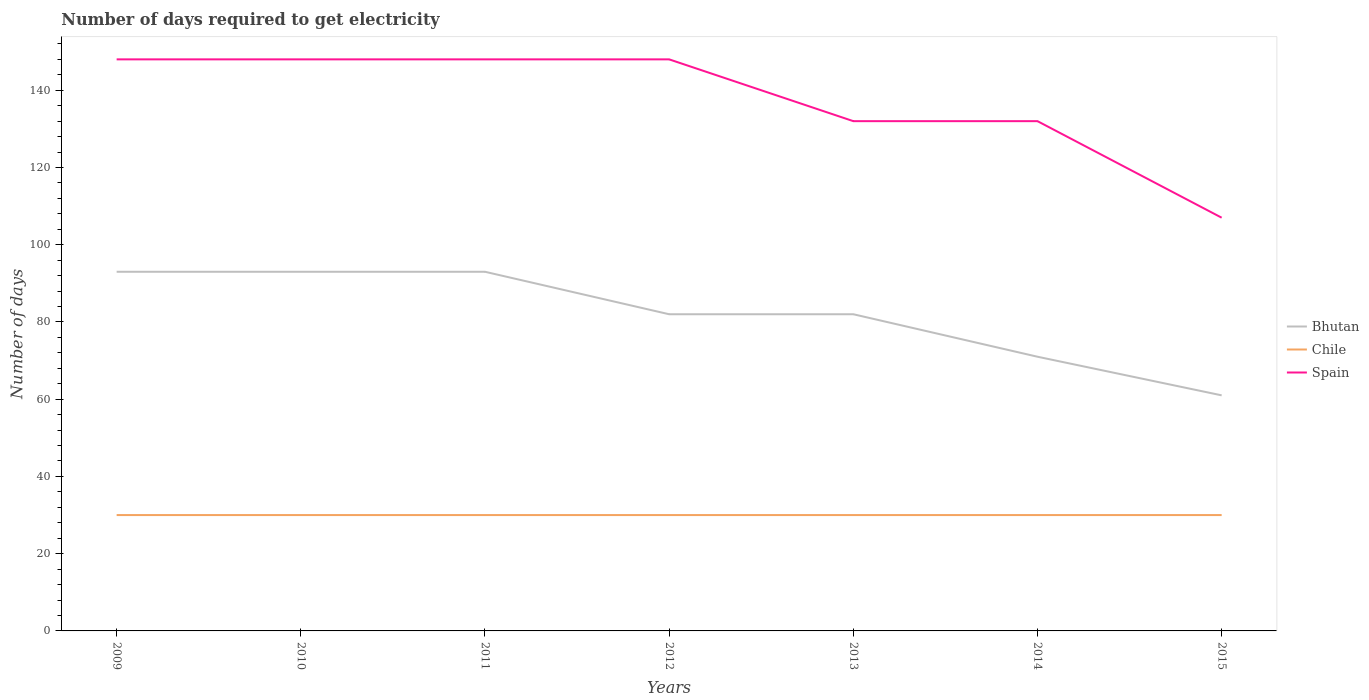Is the number of lines equal to the number of legend labels?
Provide a short and direct response. Yes. Across all years, what is the maximum number of days required to get electricity in in Chile?
Make the answer very short. 30. In which year was the number of days required to get electricity in in Bhutan maximum?
Your answer should be very brief. 2015. What is the total number of days required to get electricity in in Spain in the graph?
Keep it short and to the point. 0. What is the difference between the highest and the second highest number of days required to get electricity in in Chile?
Keep it short and to the point. 0. Is the number of days required to get electricity in in Spain strictly greater than the number of days required to get electricity in in Chile over the years?
Offer a very short reply. No. Where does the legend appear in the graph?
Your answer should be compact. Center right. How many legend labels are there?
Your answer should be very brief. 3. How are the legend labels stacked?
Your answer should be very brief. Vertical. What is the title of the graph?
Your response must be concise. Number of days required to get electricity. What is the label or title of the Y-axis?
Make the answer very short. Number of days. What is the Number of days of Bhutan in 2009?
Provide a succinct answer. 93. What is the Number of days in Spain in 2009?
Ensure brevity in your answer.  148. What is the Number of days in Bhutan in 2010?
Keep it short and to the point. 93. What is the Number of days of Chile in 2010?
Provide a short and direct response. 30. What is the Number of days in Spain in 2010?
Provide a succinct answer. 148. What is the Number of days in Bhutan in 2011?
Your answer should be very brief. 93. What is the Number of days of Chile in 2011?
Your answer should be very brief. 30. What is the Number of days of Spain in 2011?
Give a very brief answer. 148. What is the Number of days of Spain in 2012?
Your response must be concise. 148. What is the Number of days of Bhutan in 2013?
Ensure brevity in your answer.  82. What is the Number of days in Spain in 2013?
Your answer should be very brief. 132. What is the Number of days of Spain in 2014?
Provide a short and direct response. 132. What is the Number of days in Chile in 2015?
Your answer should be very brief. 30. What is the Number of days in Spain in 2015?
Give a very brief answer. 107. Across all years, what is the maximum Number of days of Bhutan?
Provide a short and direct response. 93. Across all years, what is the maximum Number of days of Spain?
Your answer should be compact. 148. Across all years, what is the minimum Number of days in Bhutan?
Provide a succinct answer. 61. Across all years, what is the minimum Number of days in Spain?
Keep it short and to the point. 107. What is the total Number of days in Bhutan in the graph?
Your answer should be very brief. 575. What is the total Number of days of Chile in the graph?
Give a very brief answer. 210. What is the total Number of days in Spain in the graph?
Offer a terse response. 963. What is the difference between the Number of days in Chile in 2009 and that in 2010?
Offer a very short reply. 0. What is the difference between the Number of days in Spain in 2009 and that in 2010?
Provide a short and direct response. 0. What is the difference between the Number of days of Spain in 2009 and that in 2011?
Provide a short and direct response. 0. What is the difference between the Number of days in Chile in 2009 and that in 2012?
Provide a short and direct response. 0. What is the difference between the Number of days in Bhutan in 2009 and that in 2013?
Your response must be concise. 11. What is the difference between the Number of days in Chile in 2009 and that in 2013?
Make the answer very short. 0. What is the difference between the Number of days in Bhutan in 2009 and that in 2014?
Make the answer very short. 22. What is the difference between the Number of days in Chile in 2009 and that in 2014?
Your answer should be compact. 0. What is the difference between the Number of days in Bhutan in 2009 and that in 2015?
Your answer should be very brief. 32. What is the difference between the Number of days of Chile in 2009 and that in 2015?
Provide a short and direct response. 0. What is the difference between the Number of days of Spain in 2009 and that in 2015?
Give a very brief answer. 41. What is the difference between the Number of days of Chile in 2010 and that in 2011?
Ensure brevity in your answer.  0. What is the difference between the Number of days in Chile in 2010 and that in 2014?
Your answer should be compact. 0. What is the difference between the Number of days of Spain in 2010 and that in 2014?
Keep it short and to the point. 16. What is the difference between the Number of days of Chile in 2010 and that in 2015?
Provide a short and direct response. 0. What is the difference between the Number of days in Chile in 2011 and that in 2012?
Your answer should be compact. 0. What is the difference between the Number of days in Spain in 2011 and that in 2013?
Offer a terse response. 16. What is the difference between the Number of days of Chile in 2011 and that in 2014?
Provide a succinct answer. 0. What is the difference between the Number of days of Spain in 2011 and that in 2014?
Offer a terse response. 16. What is the difference between the Number of days in Spain in 2011 and that in 2015?
Ensure brevity in your answer.  41. What is the difference between the Number of days of Chile in 2012 and that in 2013?
Make the answer very short. 0. What is the difference between the Number of days of Bhutan in 2012 and that in 2014?
Keep it short and to the point. 11. What is the difference between the Number of days in Chile in 2012 and that in 2014?
Your answer should be very brief. 0. What is the difference between the Number of days in Spain in 2012 and that in 2014?
Your response must be concise. 16. What is the difference between the Number of days in Bhutan in 2012 and that in 2015?
Offer a terse response. 21. What is the difference between the Number of days of Bhutan in 2013 and that in 2014?
Offer a terse response. 11. What is the difference between the Number of days in Chile in 2013 and that in 2015?
Give a very brief answer. 0. What is the difference between the Number of days in Spain in 2013 and that in 2015?
Offer a terse response. 25. What is the difference between the Number of days in Bhutan in 2014 and that in 2015?
Ensure brevity in your answer.  10. What is the difference between the Number of days in Chile in 2014 and that in 2015?
Your answer should be very brief. 0. What is the difference between the Number of days in Bhutan in 2009 and the Number of days in Chile in 2010?
Offer a terse response. 63. What is the difference between the Number of days of Bhutan in 2009 and the Number of days of Spain in 2010?
Keep it short and to the point. -55. What is the difference between the Number of days of Chile in 2009 and the Number of days of Spain in 2010?
Your response must be concise. -118. What is the difference between the Number of days in Bhutan in 2009 and the Number of days in Chile in 2011?
Ensure brevity in your answer.  63. What is the difference between the Number of days of Bhutan in 2009 and the Number of days of Spain in 2011?
Your answer should be compact. -55. What is the difference between the Number of days in Chile in 2009 and the Number of days in Spain in 2011?
Offer a very short reply. -118. What is the difference between the Number of days of Bhutan in 2009 and the Number of days of Chile in 2012?
Provide a succinct answer. 63. What is the difference between the Number of days of Bhutan in 2009 and the Number of days of Spain in 2012?
Provide a short and direct response. -55. What is the difference between the Number of days in Chile in 2009 and the Number of days in Spain in 2012?
Your answer should be compact. -118. What is the difference between the Number of days in Bhutan in 2009 and the Number of days in Chile in 2013?
Your response must be concise. 63. What is the difference between the Number of days of Bhutan in 2009 and the Number of days of Spain in 2013?
Provide a short and direct response. -39. What is the difference between the Number of days in Chile in 2009 and the Number of days in Spain in 2013?
Your response must be concise. -102. What is the difference between the Number of days of Bhutan in 2009 and the Number of days of Spain in 2014?
Keep it short and to the point. -39. What is the difference between the Number of days of Chile in 2009 and the Number of days of Spain in 2014?
Ensure brevity in your answer.  -102. What is the difference between the Number of days in Bhutan in 2009 and the Number of days in Chile in 2015?
Ensure brevity in your answer.  63. What is the difference between the Number of days of Bhutan in 2009 and the Number of days of Spain in 2015?
Provide a succinct answer. -14. What is the difference between the Number of days in Chile in 2009 and the Number of days in Spain in 2015?
Your response must be concise. -77. What is the difference between the Number of days of Bhutan in 2010 and the Number of days of Chile in 2011?
Provide a short and direct response. 63. What is the difference between the Number of days in Bhutan in 2010 and the Number of days in Spain in 2011?
Your answer should be compact. -55. What is the difference between the Number of days in Chile in 2010 and the Number of days in Spain in 2011?
Offer a very short reply. -118. What is the difference between the Number of days of Bhutan in 2010 and the Number of days of Spain in 2012?
Offer a very short reply. -55. What is the difference between the Number of days of Chile in 2010 and the Number of days of Spain in 2012?
Offer a terse response. -118. What is the difference between the Number of days in Bhutan in 2010 and the Number of days in Chile in 2013?
Provide a succinct answer. 63. What is the difference between the Number of days of Bhutan in 2010 and the Number of days of Spain in 2013?
Your answer should be very brief. -39. What is the difference between the Number of days in Chile in 2010 and the Number of days in Spain in 2013?
Offer a very short reply. -102. What is the difference between the Number of days in Bhutan in 2010 and the Number of days in Spain in 2014?
Offer a very short reply. -39. What is the difference between the Number of days in Chile in 2010 and the Number of days in Spain in 2014?
Your answer should be compact. -102. What is the difference between the Number of days in Bhutan in 2010 and the Number of days in Chile in 2015?
Offer a terse response. 63. What is the difference between the Number of days in Chile in 2010 and the Number of days in Spain in 2015?
Your answer should be compact. -77. What is the difference between the Number of days in Bhutan in 2011 and the Number of days in Spain in 2012?
Ensure brevity in your answer.  -55. What is the difference between the Number of days in Chile in 2011 and the Number of days in Spain in 2012?
Offer a terse response. -118. What is the difference between the Number of days in Bhutan in 2011 and the Number of days in Chile in 2013?
Your response must be concise. 63. What is the difference between the Number of days in Bhutan in 2011 and the Number of days in Spain in 2013?
Your response must be concise. -39. What is the difference between the Number of days of Chile in 2011 and the Number of days of Spain in 2013?
Give a very brief answer. -102. What is the difference between the Number of days of Bhutan in 2011 and the Number of days of Spain in 2014?
Provide a short and direct response. -39. What is the difference between the Number of days of Chile in 2011 and the Number of days of Spain in 2014?
Ensure brevity in your answer.  -102. What is the difference between the Number of days of Bhutan in 2011 and the Number of days of Chile in 2015?
Keep it short and to the point. 63. What is the difference between the Number of days of Bhutan in 2011 and the Number of days of Spain in 2015?
Provide a succinct answer. -14. What is the difference between the Number of days of Chile in 2011 and the Number of days of Spain in 2015?
Keep it short and to the point. -77. What is the difference between the Number of days of Bhutan in 2012 and the Number of days of Chile in 2013?
Provide a succinct answer. 52. What is the difference between the Number of days of Bhutan in 2012 and the Number of days of Spain in 2013?
Make the answer very short. -50. What is the difference between the Number of days in Chile in 2012 and the Number of days in Spain in 2013?
Your answer should be compact. -102. What is the difference between the Number of days of Chile in 2012 and the Number of days of Spain in 2014?
Make the answer very short. -102. What is the difference between the Number of days of Bhutan in 2012 and the Number of days of Chile in 2015?
Offer a very short reply. 52. What is the difference between the Number of days in Chile in 2012 and the Number of days in Spain in 2015?
Ensure brevity in your answer.  -77. What is the difference between the Number of days in Bhutan in 2013 and the Number of days in Chile in 2014?
Your response must be concise. 52. What is the difference between the Number of days of Bhutan in 2013 and the Number of days of Spain in 2014?
Provide a succinct answer. -50. What is the difference between the Number of days in Chile in 2013 and the Number of days in Spain in 2014?
Offer a terse response. -102. What is the difference between the Number of days of Bhutan in 2013 and the Number of days of Chile in 2015?
Ensure brevity in your answer.  52. What is the difference between the Number of days in Chile in 2013 and the Number of days in Spain in 2015?
Ensure brevity in your answer.  -77. What is the difference between the Number of days of Bhutan in 2014 and the Number of days of Spain in 2015?
Your response must be concise. -36. What is the difference between the Number of days in Chile in 2014 and the Number of days in Spain in 2015?
Keep it short and to the point. -77. What is the average Number of days in Bhutan per year?
Your response must be concise. 82.14. What is the average Number of days in Chile per year?
Offer a very short reply. 30. What is the average Number of days in Spain per year?
Your answer should be very brief. 137.57. In the year 2009, what is the difference between the Number of days of Bhutan and Number of days of Spain?
Your answer should be compact. -55. In the year 2009, what is the difference between the Number of days in Chile and Number of days in Spain?
Your response must be concise. -118. In the year 2010, what is the difference between the Number of days of Bhutan and Number of days of Spain?
Provide a succinct answer. -55. In the year 2010, what is the difference between the Number of days in Chile and Number of days in Spain?
Provide a short and direct response. -118. In the year 2011, what is the difference between the Number of days of Bhutan and Number of days of Spain?
Provide a short and direct response. -55. In the year 2011, what is the difference between the Number of days in Chile and Number of days in Spain?
Your response must be concise. -118. In the year 2012, what is the difference between the Number of days in Bhutan and Number of days in Chile?
Keep it short and to the point. 52. In the year 2012, what is the difference between the Number of days in Bhutan and Number of days in Spain?
Keep it short and to the point. -66. In the year 2012, what is the difference between the Number of days of Chile and Number of days of Spain?
Give a very brief answer. -118. In the year 2013, what is the difference between the Number of days of Bhutan and Number of days of Chile?
Your answer should be very brief. 52. In the year 2013, what is the difference between the Number of days of Bhutan and Number of days of Spain?
Make the answer very short. -50. In the year 2013, what is the difference between the Number of days of Chile and Number of days of Spain?
Offer a terse response. -102. In the year 2014, what is the difference between the Number of days of Bhutan and Number of days of Spain?
Provide a succinct answer. -61. In the year 2014, what is the difference between the Number of days of Chile and Number of days of Spain?
Ensure brevity in your answer.  -102. In the year 2015, what is the difference between the Number of days of Bhutan and Number of days of Chile?
Your answer should be compact. 31. In the year 2015, what is the difference between the Number of days of Bhutan and Number of days of Spain?
Your answer should be very brief. -46. In the year 2015, what is the difference between the Number of days in Chile and Number of days in Spain?
Offer a terse response. -77. What is the ratio of the Number of days of Spain in 2009 to that in 2010?
Make the answer very short. 1. What is the ratio of the Number of days in Bhutan in 2009 to that in 2012?
Ensure brevity in your answer.  1.13. What is the ratio of the Number of days of Chile in 2009 to that in 2012?
Make the answer very short. 1. What is the ratio of the Number of days in Bhutan in 2009 to that in 2013?
Provide a succinct answer. 1.13. What is the ratio of the Number of days of Chile in 2009 to that in 2013?
Provide a short and direct response. 1. What is the ratio of the Number of days in Spain in 2009 to that in 2013?
Make the answer very short. 1.12. What is the ratio of the Number of days of Bhutan in 2009 to that in 2014?
Your answer should be very brief. 1.31. What is the ratio of the Number of days in Spain in 2009 to that in 2014?
Provide a short and direct response. 1.12. What is the ratio of the Number of days of Bhutan in 2009 to that in 2015?
Your answer should be very brief. 1.52. What is the ratio of the Number of days in Chile in 2009 to that in 2015?
Provide a succinct answer. 1. What is the ratio of the Number of days of Spain in 2009 to that in 2015?
Keep it short and to the point. 1.38. What is the ratio of the Number of days of Bhutan in 2010 to that in 2011?
Your answer should be compact. 1. What is the ratio of the Number of days in Chile in 2010 to that in 2011?
Give a very brief answer. 1. What is the ratio of the Number of days of Spain in 2010 to that in 2011?
Offer a terse response. 1. What is the ratio of the Number of days in Bhutan in 2010 to that in 2012?
Your response must be concise. 1.13. What is the ratio of the Number of days in Bhutan in 2010 to that in 2013?
Keep it short and to the point. 1.13. What is the ratio of the Number of days of Spain in 2010 to that in 2013?
Provide a short and direct response. 1.12. What is the ratio of the Number of days in Bhutan in 2010 to that in 2014?
Provide a short and direct response. 1.31. What is the ratio of the Number of days of Spain in 2010 to that in 2014?
Your response must be concise. 1.12. What is the ratio of the Number of days of Bhutan in 2010 to that in 2015?
Keep it short and to the point. 1.52. What is the ratio of the Number of days of Spain in 2010 to that in 2015?
Make the answer very short. 1.38. What is the ratio of the Number of days of Bhutan in 2011 to that in 2012?
Ensure brevity in your answer.  1.13. What is the ratio of the Number of days in Spain in 2011 to that in 2012?
Your response must be concise. 1. What is the ratio of the Number of days of Bhutan in 2011 to that in 2013?
Your answer should be very brief. 1.13. What is the ratio of the Number of days of Spain in 2011 to that in 2013?
Your answer should be compact. 1.12. What is the ratio of the Number of days in Bhutan in 2011 to that in 2014?
Your response must be concise. 1.31. What is the ratio of the Number of days of Spain in 2011 to that in 2014?
Provide a short and direct response. 1.12. What is the ratio of the Number of days of Bhutan in 2011 to that in 2015?
Your answer should be very brief. 1.52. What is the ratio of the Number of days of Spain in 2011 to that in 2015?
Ensure brevity in your answer.  1.38. What is the ratio of the Number of days in Bhutan in 2012 to that in 2013?
Your response must be concise. 1. What is the ratio of the Number of days in Chile in 2012 to that in 2013?
Your answer should be very brief. 1. What is the ratio of the Number of days in Spain in 2012 to that in 2013?
Provide a succinct answer. 1.12. What is the ratio of the Number of days of Bhutan in 2012 to that in 2014?
Your answer should be compact. 1.15. What is the ratio of the Number of days of Chile in 2012 to that in 2014?
Your response must be concise. 1. What is the ratio of the Number of days of Spain in 2012 to that in 2014?
Provide a short and direct response. 1.12. What is the ratio of the Number of days in Bhutan in 2012 to that in 2015?
Your response must be concise. 1.34. What is the ratio of the Number of days in Chile in 2012 to that in 2015?
Your answer should be very brief. 1. What is the ratio of the Number of days of Spain in 2012 to that in 2015?
Give a very brief answer. 1.38. What is the ratio of the Number of days of Bhutan in 2013 to that in 2014?
Provide a short and direct response. 1.15. What is the ratio of the Number of days of Spain in 2013 to that in 2014?
Provide a short and direct response. 1. What is the ratio of the Number of days in Bhutan in 2013 to that in 2015?
Ensure brevity in your answer.  1.34. What is the ratio of the Number of days of Spain in 2013 to that in 2015?
Your answer should be compact. 1.23. What is the ratio of the Number of days of Bhutan in 2014 to that in 2015?
Your response must be concise. 1.16. What is the ratio of the Number of days of Spain in 2014 to that in 2015?
Offer a terse response. 1.23. What is the difference between the highest and the second highest Number of days of Bhutan?
Provide a short and direct response. 0. What is the difference between the highest and the second highest Number of days in Chile?
Your answer should be very brief. 0. What is the difference between the highest and the lowest Number of days in Bhutan?
Your answer should be compact. 32. 